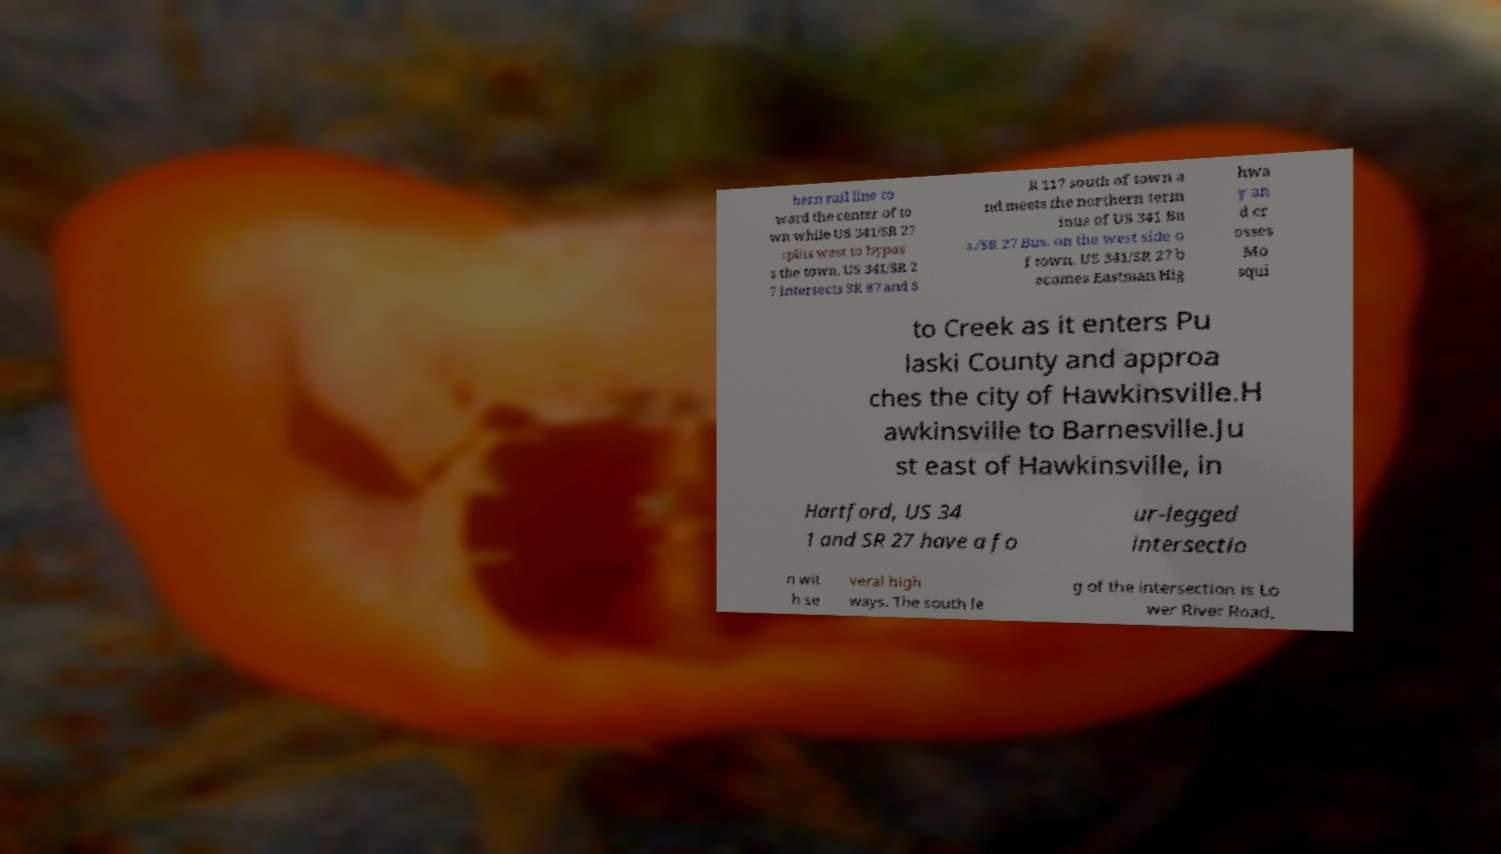Can you read and provide the text displayed in the image?This photo seems to have some interesting text. Can you extract and type it out for me? hern rail line to ward the center of to wn while US 341/SR 27 splits west to bypas s the town. US 341/SR 2 7 intersects SR 87 and S R 117 south of town a nd meets the northern term inus of US 341 Bu s./SR 27 Bus. on the west side o f town. US 341/SR 27 b ecomes Eastman Hig hwa y an d cr osses Mo squi to Creek as it enters Pu laski County and approa ches the city of Hawkinsville.H awkinsville to Barnesville.Ju st east of Hawkinsville, in Hartford, US 34 1 and SR 27 have a fo ur-legged intersectio n wit h se veral high ways. The south le g of the intersection is Lo wer River Road, 